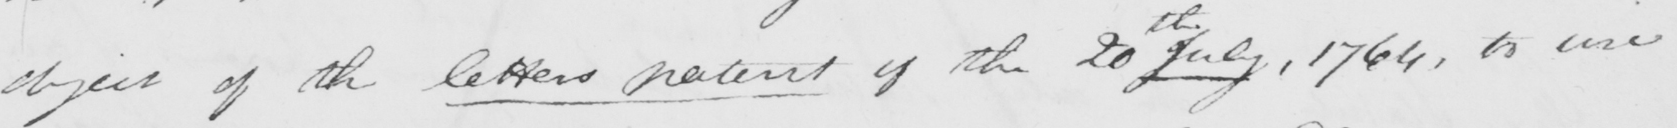Please provide the text content of this handwritten line. object of the letters patent of the 20th July , 1766 , to use 